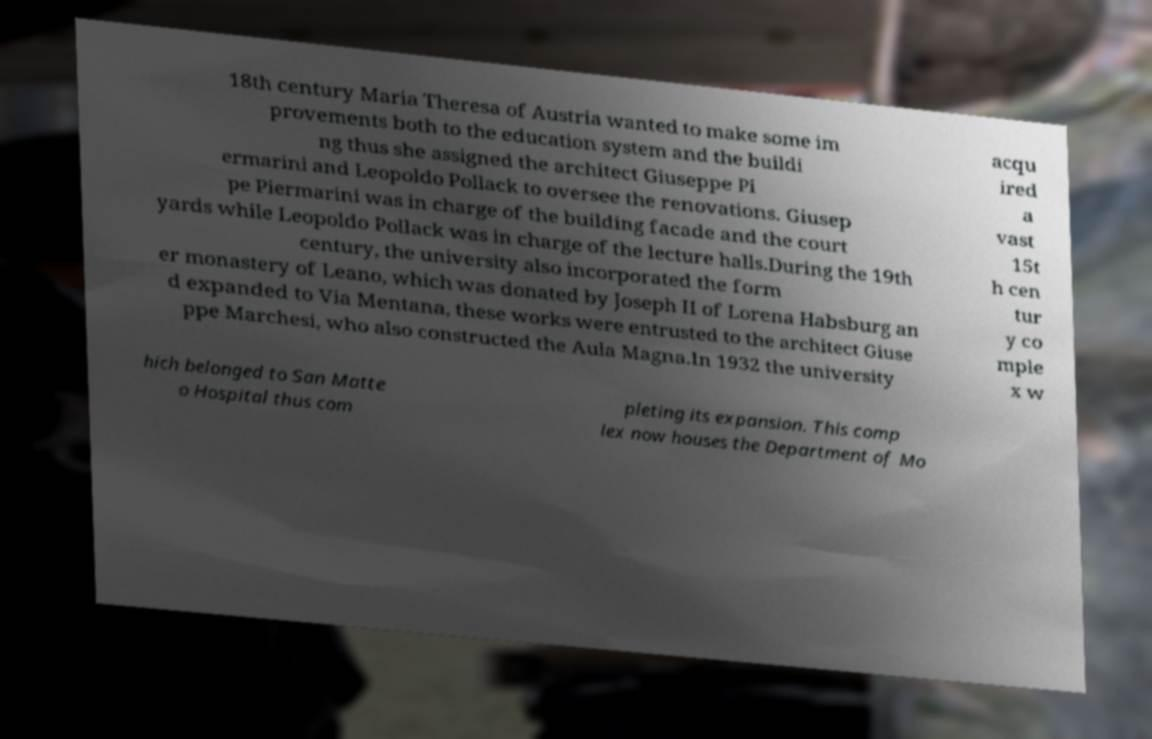What messages or text are displayed in this image? I need them in a readable, typed format. 18th century Maria Theresa of Austria wanted to make some im provements both to the education system and the buildi ng thus she assigned the architect Giuseppe Pi ermarini and Leopoldo Pollack to oversee the renovations. Giusep pe Piermarini was in charge of the building facade and the court yards while Leopoldo Pollack was in charge of the lecture halls.During the 19th century, the university also incorporated the form er monastery of Leano, which was donated by Joseph II of Lorena Habsburg an d expanded to Via Mentana, these works were entrusted to the architect Giuse ppe Marchesi, who also constructed the Aula Magna.In 1932 the university acqu ired a vast 15t h cen tur y co mple x w hich belonged to San Matte o Hospital thus com pleting its expansion. This comp lex now houses the Department of Mo 